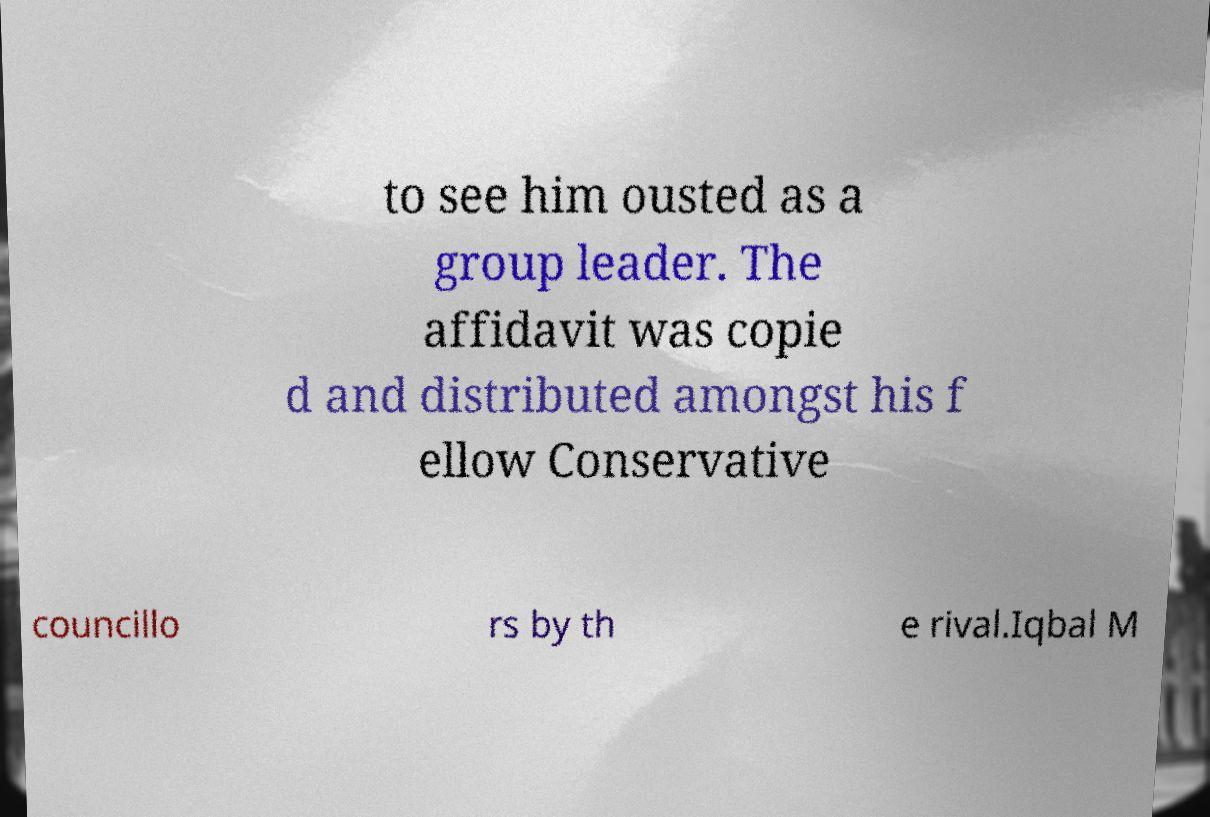There's text embedded in this image that I need extracted. Can you transcribe it verbatim? to see him ousted as a group leader. The affidavit was copie d and distributed amongst his f ellow Conservative councillo rs by th e rival.Iqbal M 